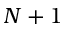<formula> <loc_0><loc_0><loc_500><loc_500>N + 1</formula> 